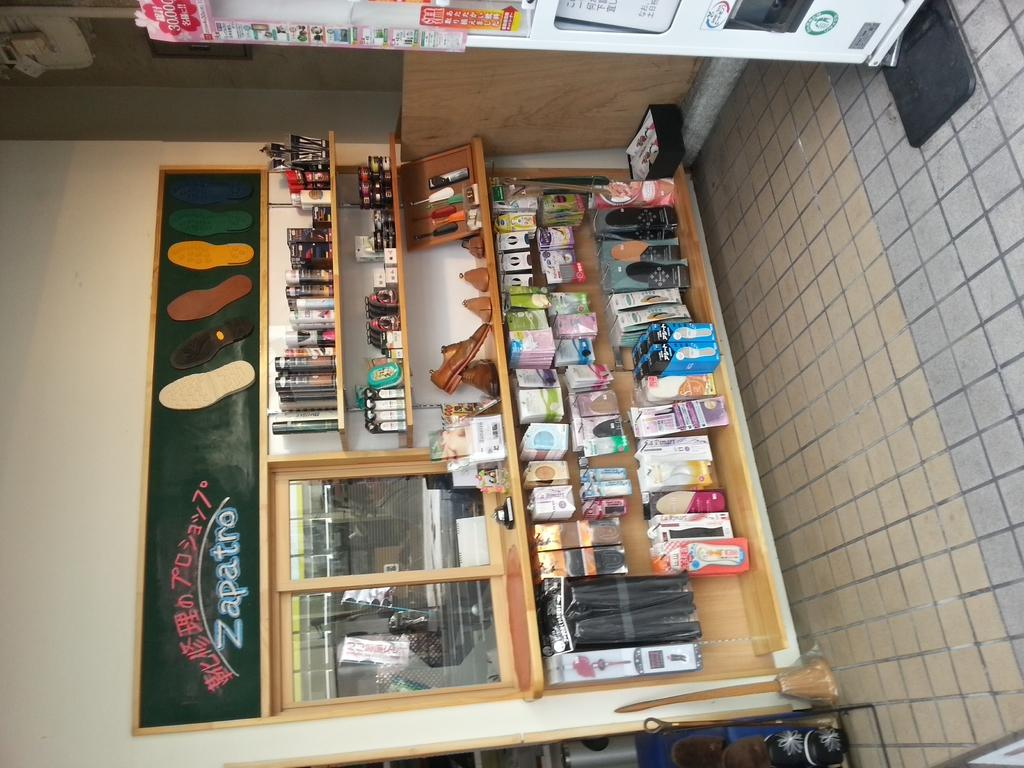<image>
Create a compact narrative representing the image presented. an inside of a shoe shop with a sign saying Zapatro 